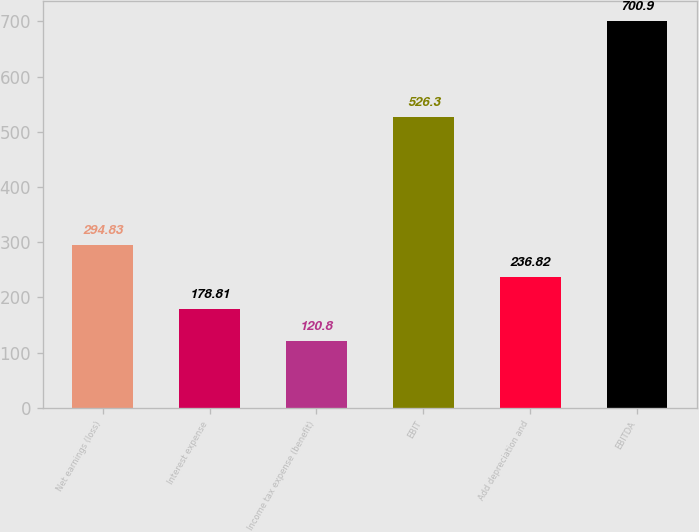Convert chart to OTSL. <chart><loc_0><loc_0><loc_500><loc_500><bar_chart><fcel>Net earnings (loss)<fcel>Interest expense<fcel>Income tax expense (benefit)<fcel>EBIT<fcel>Add depreciation and<fcel>EBITDA<nl><fcel>294.83<fcel>178.81<fcel>120.8<fcel>526.3<fcel>236.82<fcel>700.9<nl></chart> 